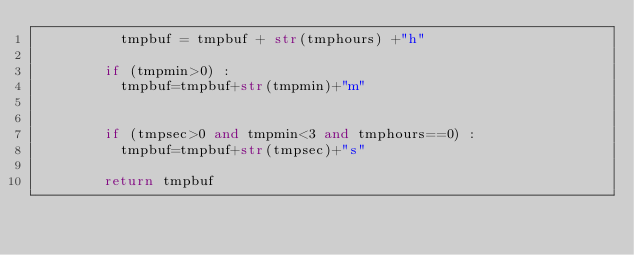<code> <loc_0><loc_0><loc_500><loc_500><_Python_>          tmpbuf = tmpbuf + str(tmphours) +"h"
         
        if (tmpmin>0) :
          tmpbuf=tmpbuf+str(tmpmin)+"m"

        
        if (tmpsec>0 and tmpmin<3 and tmphours==0) :
          tmpbuf=tmpbuf+str(tmpsec)+"s"

        return tmpbuf



</code> 